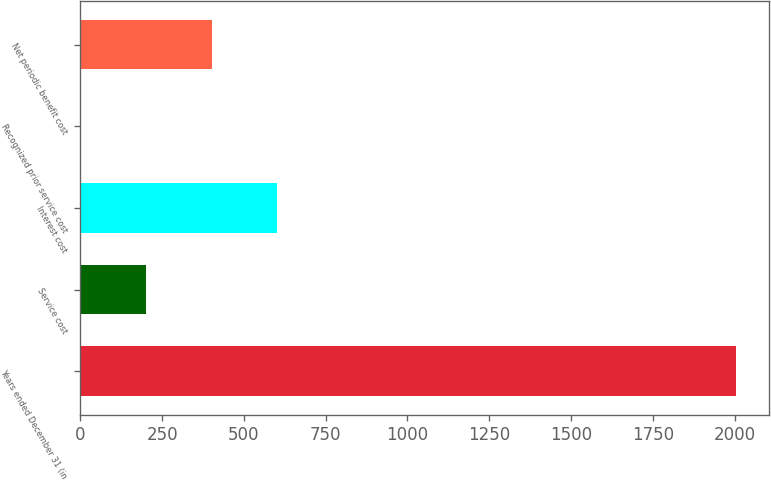<chart> <loc_0><loc_0><loc_500><loc_500><bar_chart><fcel>Years ended December 31 (in<fcel>Service cost<fcel>Interest cost<fcel>Recognized prior service cost<fcel>Net periodic benefit cost<nl><fcel>2005<fcel>200.59<fcel>601.57<fcel>0.1<fcel>401.08<nl></chart> 